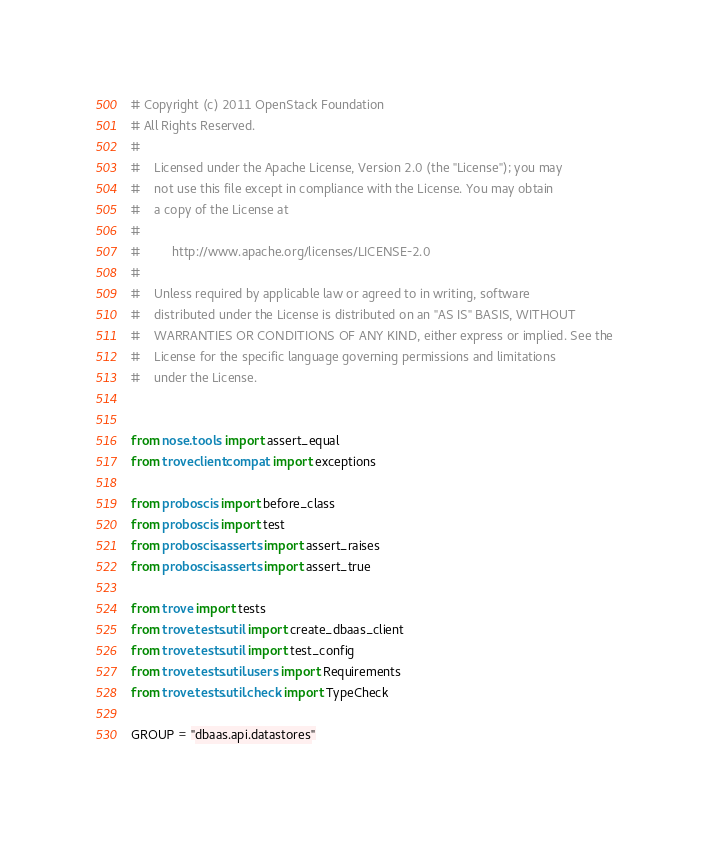<code> <loc_0><loc_0><loc_500><loc_500><_Python_># Copyright (c) 2011 OpenStack Foundation
# All Rights Reserved.
#
#    Licensed under the Apache License, Version 2.0 (the "License"); you may
#    not use this file except in compliance with the License. You may obtain
#    a copy of the License at
#
#         http://www.apache.org/licenses/LICENSE-2.0
#
#    Unless required by applicable law or agreed to in writing, software
#    distributed under the License is distributed on an "AS IS" BASIS, WITHOUT
#    WARRANTIES OR CONDITIONS OF ANY KIND, either express or implied. See the
#    License for the specific language governing permissions and limitations
#    under the License.


from nose.tools import assert_equal
from troveclient.compat import exceptions

from proboscis import before_class
from proboscis import test
from proboscis.asserts import assert_raises
from proboscis.asserts import assert_true

from trove import tests
from trove.tests.util import create_dbaas_client
from trove.tests.util import test_config
from trove.tests.util.users import Requirements
from trove.tests.util.check import TypeCheck

GROUP = "dbaas.api.datastores"</code> 